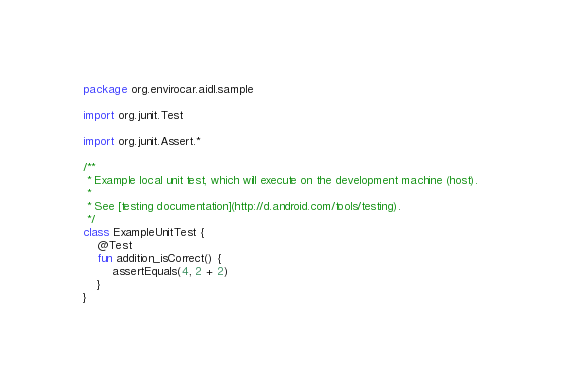<code> <loc_0><loc_0><loc_500><loc_500><_Kotlin_>package org.envirocar.aidl.sample

import org.junit.Test

import org.junit.Assert.*

/**
 * Example local unit test, which will execute on the development machine (host).
 *
 * See [testing documentation](http://d.android.com/tools/testing).
 */
class ExampleUnitTest {
    @Test
    fun addition_isCorrect() {
        assertEquals(4, 2 + 2)
    }
}
</code> 